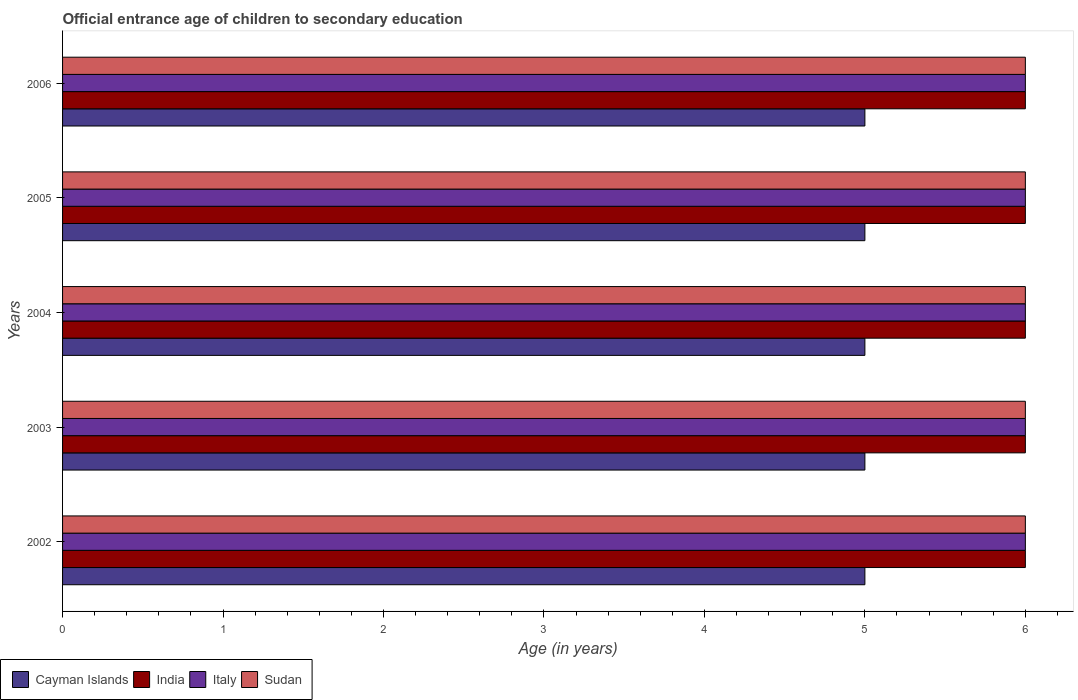How many different coloured bars are there?
Ensure brevity in your answer.  4. How many groups of bars are there?
Provide a short and direct response. 5. Are the number of bars per tick equal to the number of legend labels?
Ensure brevity in your answer.  Yes. How many bars are there on the 3rd tick from the top?
Offer a terse response. 4. What is the secondary school starting age of children in Sudan in 2004?
Make the answer very short. 6. Across all years, what is the maximum secondary school starting age of children in Cayman Islands?
Ensure brevity in your answer.  5. In which year was the secondary school starting age of children in Italy maximum?
Make the answer very short. 2002. In which year was the secondary school starting age of children in India minimum?
Your answer should be very brief. 2002. What is the total secondary school starting age of children in Cayman Islands in the graph?
Offer a terse response. 25. What is the difference between the secondary school starting age of children in Italy in 2004 and that in 2006?
Your answer should be compact. 0. What is the difference between the secondary school starting age of children in Cayman Islands in 2006 and the secondary school starting age of children in Italy in 2003?
Your answer should be compact. -1. In the year 2004, what is the difference between the secondary school starting age of children in Cayman Islands and secondary school starting age of children in Sudan?
Your response must be concise. -1. In how many years, is the secondary school starting age of children in India greater than 0.6000000000000001 years?
Keep it short and to the point. 5. What is the ratio of the secondary school starting age of children in Italy in 2002 to that in 2006?
Give a very brief answer. 1. Is the difference between the secondary school starting age of children in Cayman Islands in 2003 and 2006 greater than the difference between the secondary school starting age of children in Sudan in 2003 and 2006?
Provide a succinct answer. No. What is the difference between the highest and the second highest secondary school starting age of children in Sudan?
Your answer should be very brief. 0. Is it the case that in every year, the sum of the secondary school starting age of children in Sudan and secondary school starting age of children in India is greater than the sum of secondary school starting age of children in Italy and secondary school starting age of children in Cayman Islands?
Give a very brief answer. No. What does the 2nd bar from the top in 2004 represents?
Keep it short and to the point. Italy. How many bars are there?
Ensure brevity in your answer.  20. How many years are there in the graph?
Provide a succinct answer. 5. What is the difference between two consecutive major ticks on the X-axis?
Provide a short and direct response. 1. Does the graph contain any zero values?
Ensure brevity in your answer.  No. Does the graph contain grids?
Offer a very short reply. No. Where does the legend appear in the graph?
Keep it short and to the point. Bottom left. How are the legend labels stacked?
Provide a short and direct response. Horizontal. What is the title of the graph?
Provide a succinct answer. Official entrance age of children to secondary education. Does "Namibia" appear as one of the legend labels in the graph?
Offer a terse response. No. What is the label or title of the X-axis?
Provide a succinct answer. Age (in years). What is the label or title of the Y-axis?
Your answer should be compact. Years. What is the Age (in years) in Cayman Islands in 2002?
Keep it short and to the point. 5. What is the Age (in years) in India in 2002?
Ensure brevity in your answer.  6. What is the Age (in years) in Italy in 2002?
Provide a succinct answer. 6. What is the Age (in years) in Sudan in 2002?
Your answer should be very brief. 6. What is the Age (in years) of Cayman Islands in 2003?
Offer a very short reply. 5. What is the Age (in years) of Cayman Islands in 2004?
Ensure brevity in your answer.  5. What is the Age (in years) of India in 2005?
Give a very brief answer. 6. What is the Age (in years) of Italy in 2005?
Your answer should be very brief. 6. What is the Age (in years) in Sudan in 2005?
Provide a succinct answer. 6. What is the Age (in years) in Cayman Islands in 2006?
Keep it short and to the point. 5. What is the Age (in years) of India in 2006?
Your answer should be very brief. 6. Across all years, what is the maximum Age (in years) of India?
Offer a very short reply. 6. Across all years, what is the maximum Age (in years) in Sudan?
Your response must be concise. 6. Across all years, what is the minimum Age (in years) in Sudan?
Provide a succinct answer. 6. What is the total Age (in years) in India in the graph?
Ensure brevity in your answer.  30. What is the total Age (in years) in Sudan in the graph?
Offer a terse response. 30. What is the difference between the Age (in years) of India in 2002 and that in 2003?
Your answer should be compact. 0. What is the difference between the Age (in years) in Sudan in 2002 and that in 2003?
Offer a terse response. 0. What is the difference between the Age (in years) in India in 2002 and that in 2004?
Your answer should be compact. 0. What is the difference between the Age (in years) of Sudan in 2002 and that in 2004?
Provide a succinct answer. 0. What is the difference between the Age (in years) of Cayman Islands in 2002 and that in 2005?
Offer a terse response. 0. What is the difference between the Age (in years) of India in 2002 and that in 2005?
Your response must be concise. 0. What is the difference between the Age (in years) in Italy in 2002 and that in 2005?
Give a very brief answer. 0. What is the difference between the Age (in years) in India in 2002 and that in 2006?
Ensure brevity in your answer.  0. What is the difference between the Age (in years) of Italy in 2003 and that in 2004?
Keep it short and to the point. 0. What is the difference between the Age (in years) of Sudan in 2003 and that in 2004?
Your answer should be very brief. 0. What is the difference between the Age (in years) in India in 2003 and that in 2005?
Ensure brevity in your answer.  0. What is the difference between the Age (in years) of Italy in 2003 and that in 2005?
Your answer should be very brief. 0. What is the difference between the Age (in years) in Cayman Islands in 2003 and that in 2006?
Offer a very short reply. 0. What is the difference between the Age (in years) of India in 2003 and that in 2006?
Ensure brevity in your answer.  0. What is the difference between the Age (in years) in Italy in 2003 and that in 2006?
Keep it short and to the point. 0. What is the difference between the Age (in years) in Cayman Islands in 2004 and that in 2005?
Your response must be concise. 0. What is the difference between the Age (in years) of Sudan in 2004 and that in 2005?
Give a very brief answer. 0. What is the difference between the Age (in years) in Cayman Islands in 2004 and that in 2006?
Ensure brevity in your answer.  0. What is the difference between the Age (in years) in Italy in 2004 and that in 2006?
Give a very brief answer. 0. What is the difference between the Age (in years) in Italy in 2005 and that in 2006?
Ensure brevity in your answer.  0. What is the difference between the Age (in years) of Cayman Islands in 2002 and the Age (in years) of India in 2003?
Your answer should be compact. -1. What is the difference between the Age (in years) of Cayman Islands in 2002 and the Age (in years) of Italy in 2004?
Your answer should be very brief. -1. What is the difference between the Age (in years) in India in 2002 and the Age (in years) in Italy in 2004?
Give a very brief answer. 0. What is the difference between the Age (in years) in Italy in 2002 and the Age (in years) in Sudan in 2005?
Ensure brevity in your answer.  0. What is the difference between the Age (in years) of Cayman Islands in 2002 and the Age (in years) of India in 2006?
Keep it short and to the point. -1. What is the difference between the Age (in years) of Cayman Islands in 2002 and the Age (in years) of Italy in 2006?
Make the answer very short. -1. What is the difference between the Age (in years) of Cayman Islands in 2002 and the Age (in years) of Sudan in 2006?
Your answer should be compact. -1. What is the difference between the Age (in years) of India in 2002 and the Age (in years) of Italy in 2006?
Make the answer very short. 0. What is the difference between the Age (in years) of Cayman Islands in 2003 and the Age (in years) of India in 2004?
Keep it short and to the point. -1. What is the difference between the Age (in years) in Cayman Islands in 2003 and the Age (in years) in Italy in 2004?
Your response must be concise. -1. What is the difference between the Age (in years) of Cayman Islands in 2003 and the Age (in years) of Sudan in 2004?
Your response must be concise. -1. What is the difference between the Age (in years) in India in 2003 and the Age (in years) in Italy in 2004?
Provide a short and direct response. 0. What is the difference between the Age (in years) of Cayman Islands in 2003 and the Age (in years) of Sudan in 2005?
Your answer should be compact. -1. What is the difference between the Age (in years) in India in 2003 and the Age (in years) in Italy in 2005?
Your answer should be very brief. 0. What is the difference between the Age (in years) in Italy in 2003 and the Age (in years) in Sudan in 2005?
Make the answer very short. 0. What is the difference between the Age (in years) of Cayman Islands in 2003 and the Age (in years) of India in 2006?
Ensure brevity in your answer.  -1. What is the difference between the Age (in years) of India in 2003 and the Age (in years) of Italy in 2006?
Provide a short and direct response. 0. What is the difference between the Age (in years) of India in 2003 and the Age (in years) of Sudan in 2006?
Provide a succinct answer. 0. What is the difference between the Age (in years) in Cayman Islands in 2004 and the Age (in years) in Italy in 2005?
Your answer should be compact. -1. What is the difference between the Age (in years) of Cayman Islands in 2004 and the Age (in years) of Sudan in 2005?
Give a very brief answer. -1. What is the difference between the Age (in years) of India in 2004 and the Age (in years) of Italy in 2005?
Your answer should be compact. 0. What is the difference between the Age (in years) of Italy in 2004 and the Age (in years) of Sudan in 2005?
Your answer should be very brief. 0. What is the difference between the Age (in years) of Cayman Islands in 2004 and the Age (in years) of Sudan in 2006?
Give a very brief answer. -1. What is the difference between the Age (in years) of India in 2004 and the Age (in years) of Sudan in 2006?
Keep it short and to the point. 0. What is the difference between the Age (in years) in Cayman Islands in 2005 and the Age (in years) in Sudan in 2006?
Provide a short and direct response. -1. What is the difference between the Age (in years) of India in 2005 and the Age (in years) of Italy in 2006?
Offer a very short reply. 0. What is the difference between the Age (in years) of India in 2005 and the Age (in years) of Sudan in 2006?
Your response must be concise. 0. What is the difference between the Age (in years) in Italy in 2005 and the Age (in years) in Sudan in 2006?
Your answer should be very brief. 0. What is the average Age (in years) in Italy per year?
Your response must be concise. 6. What is the average Age (in years) of Sudan per year?
Keep it short and to the point. 6. In the year 2002, what is the difference between the Age (in years) of Cayman Islands and Age (in years) of India?
Your answer should be compact. -1. In the year 2002, what is the difference between the Age (in years) of Cayman Islands and Age (in years) of Sudan?
Your answer should be very brief. -1. In the year 2002, what is the difference between the Age (in years) in India and Age (in years) in Italy?
Offer a terse response. 0. In the year 2002, what is the difference between the Age (in years) of India and Age (in years) of Sudan?
Give a very brief answer. 0. In the year 2003, what is the difference between the Age (in years) of Cayman Islands and Age (in years) of India?
Your response must be concise. -1. In the year 2003, what is the difference between the Age (in years) of Cayman Islands and Age (in years) of Italy?
Keep it short and to the point. -1. In the year 2003, what is the difference between the Age (in years) in Cayman Islands and Age (in years) in Sudan?
Provide a short and direct response. -1. In the year 2004, what is the difference between the Age (in years) in Cayman Islands and Age (in years) in India?
Provide a short and direct response. -1. In the year 2004, what is the difference between the Age (in years) in Cayman Islands and Age (in years) in Sudan?
Provide a short and direct response. -1. In the year 2004, what is the difference between the Age (in years) in India and Age (in years) in Sudan?
Your response must be concise. 0. In the year 2004, what is the difference between the Age (in years) of Italy and Age (in years) of Sudan?
Your answer should be compact. 0. In the year 2005, what is the difference between the Age (in years) of Cayman Islands and Age (in years) of India?
Ensure brevity in your answer.  -1. In the year 2005, what is the difference between the Age (in years) of Cayman Islands and Age (in years) of Sudan?
Your answer should be very brief. -1. In the year 2005, what is the difference between the Age (in years) of India and Age (in years) of Italy?
Give a very brief answer. 0. In the year 2005, what is the difference between the Age (in years) in India and Age (in years) in Sudan?
Provide a short and direct response. 0. In the year 2006, what is the difference between the Age (in years) of Cayman Islands and Age (in years) of India?
Keep it short and to the point. -1. In the year 2006, what is the difference between the Age (in years) in Cayman Islands and Age (in years) in Italy?
Ensure brevity in your answer.  -1. In the year 2006, what is the difference between the Age (in years) in Italy and Age (in years) in Sudan?
Your answer should be compact. 0. What is the ratio of the Age (in years) in Italy in 2002 to that in 2003?
Give a very brief answer. 1. What is the ratio of the Age (in years) of Sudan in 2002 to that in 2003?
Keep it short and to the point. 1. What is the ratio of the Age (in years) of Cayman Islands in 2002 to that in 2004?
Provide a succinct answer. 1. What is the ratio of the Age (in years) of India in 2002 to that in 2004?
Provide a short and direct response. 1. What is the ratio of the Age (in years) in Italy in 2002 to that in 2005?
Your answer should be compact. 1. What is the ratio of the Age (in years) of India in 2003 to that in 2004?
Provide a short and direct response. 1. What is the ratio of the Age (in years) in Italy in 2003 to that in 2004?
Make the answer very short. 1. What is the ratio of the Age (in years) of India in 2003 to that in 2005?
Offer a terse response. 1. What is the ratio of the Age (in years) in Italy in 2003 to that in 2005?
Your response must be concise. 1. What is the ratio of the Age (in years) of Sudan in 2003 to that in 2005?
Your response must be concise. 1. What is the ratio of the Age (in years) in India in 2003 to that in 2006?
Offer a very short reply. 1. What is the ratio of the Age (in years) in Italy in 2003 to that in 2006?
Your answer should be very brief. 1. What is the ratio of the Age (in years) in Sudan in 2003 to that in 2006?
Your response must be concise. 1. What is the ratio of the Age (in years) in Cayman Islands in 2004 to that in 2005?
Give a very brief answer. 1. What is the ratio of the Age (in years) in Cayman Islands in 2004 to that in 2006?
Give a very brief answer. 1. What is the ratio of the Age (in years) in Italy in 2004 to that in 2006?
Provide a succinct answer. 1. What is the ratio of the Age (in years) of Sudan in 2004 to that in 2006?
Your answer should be compact. 1. What is the ratio of the Age (in years) of India in 2005 to that in 2006?
Your answer should be very brief. 1. What is the difference between the highest and the second highest Age (in years) in Cayman Islands?
Offer a very short reply. 0. What is the difference between the highest and the second highest Age (in years) of Italy?
Your response must be concise. 0. What is the difference between the highest and the second highest Age (in years) in Sudan?
Your answer should be compact. 0. What is the difference between the highest and the lowest Age (in years) of Cayman Islands?
Provide a short and direct response. 0. What is the difference between the highest and the lowest Age (in years) in India?
Ensure brevity in your answer.  0. What is the difference between the highest and the lowest Age (in years) of Italy?
Ensure brevity in your answer.  0. What is the difference between the highest and the lowest Age (in years) in Sudan?
Provide a succinct answer. 0. 